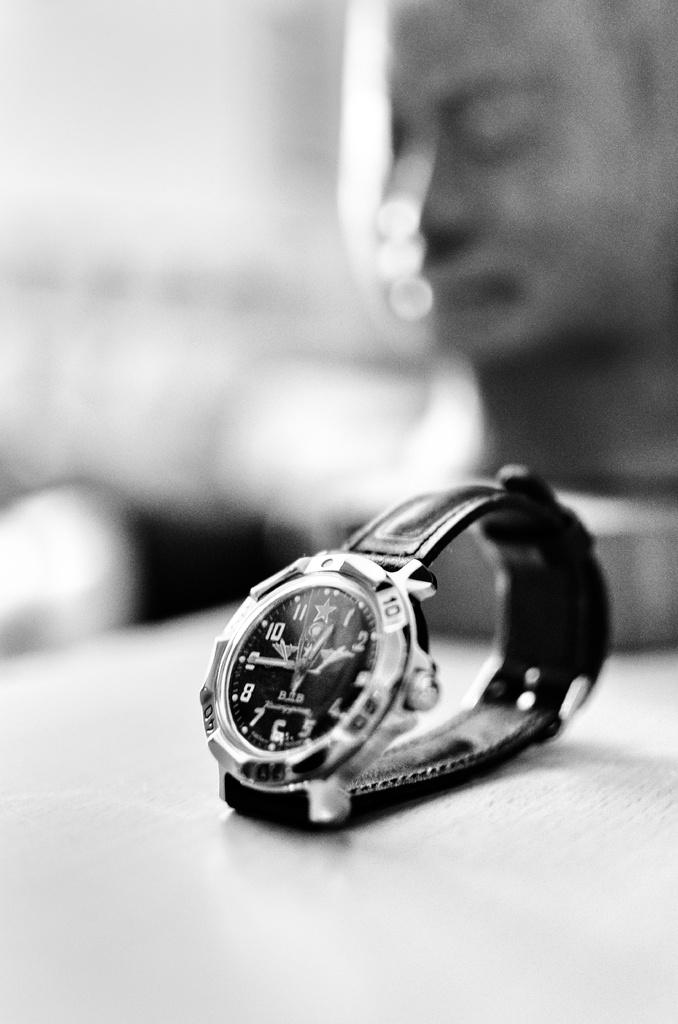<image>
Describe the image concisely. Black and silver wrist watch which says BOB on it. 